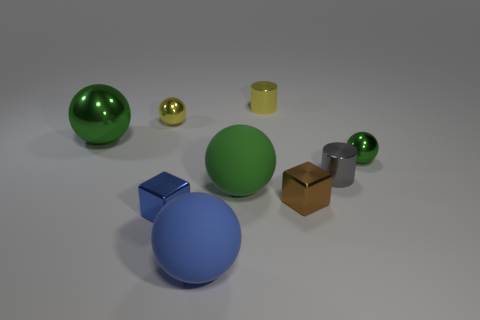Subtract all red blocks. How many green spheres are left? 3 Subtract all yellow shiny balls. How many balls are left? 4 Subtract all blue spheres. How many spheres are left? 4 Subtract all cyan balls. Subtract all gray blocks. How many balls are left? 5 Add 1 tiny brown metal objects. How many objects exist? 10 Subtract all balls. How many objects are left? 4 Subtract all large things. Subtract all green metallic balls. How many objects are left? 4 Add 5 blue metal things. How many blue metal things are left? 6 Add 6 big green rubber objects. How many big green rubber objects exist? 7 Subtract 0 cyan blocks. How many objects are left? 9 